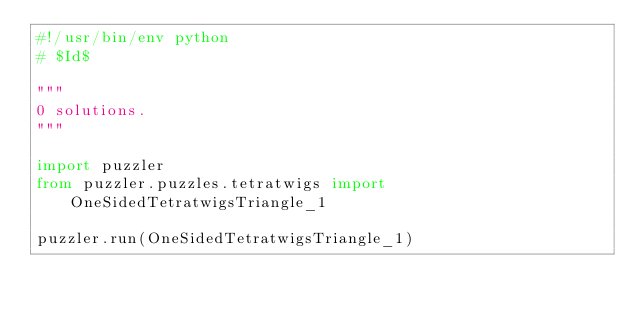<code> <loc_0><loc_0><loc_500><loc_500><_Python_>#!/usr/bin/env python
# $Id$

"""
0 solutions.
"""

import puzzler
from puzzler.puzzles.tetratwigs import OneSidedTetratwigsTriangle_1

puzzler.run(OneSidedTetratwigsTriangle_1)
</code> 